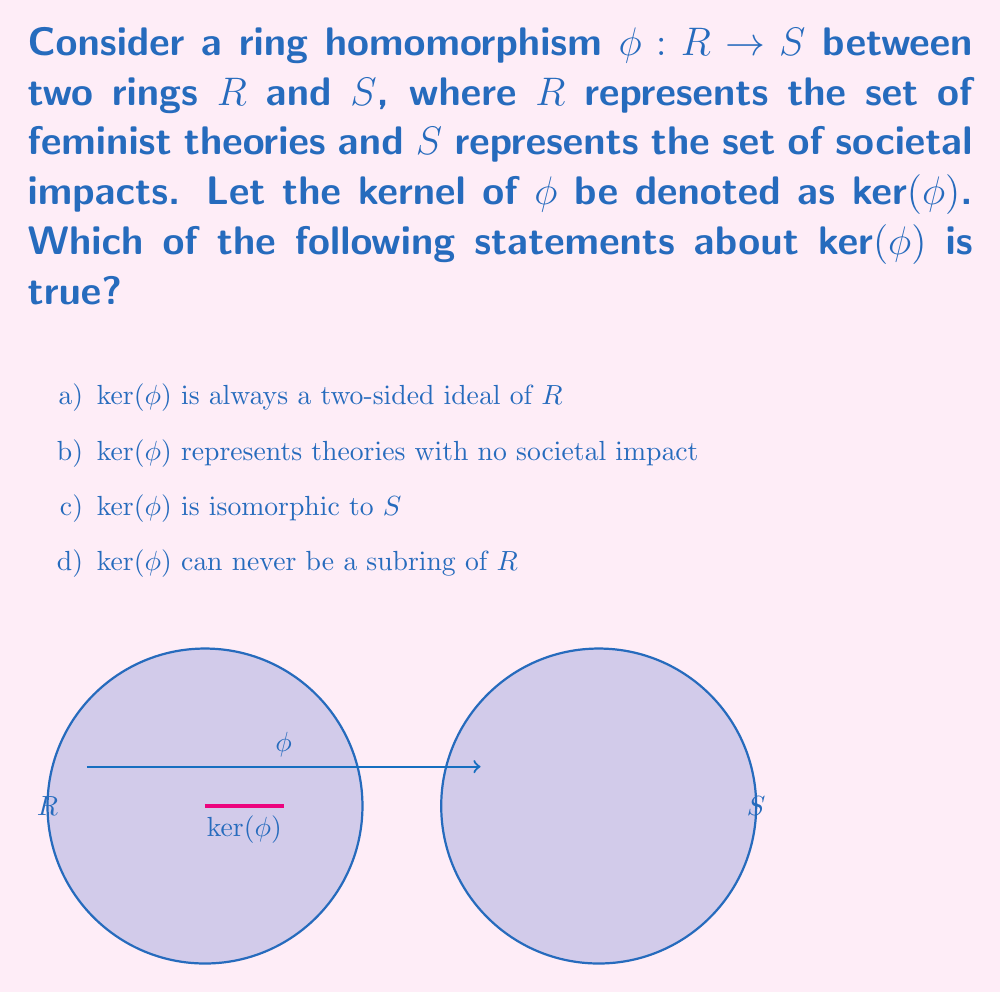Help me with this question. Let's approach this step-by-step:

1) First, recall that for a ring homomorphism $\phi: R \rightarrow S$, the kernel is defined as:

   $\text{ker}(\phi) = \{r \in R : \phi(r) = 0_S\}$

   where $0_S$ is the zero element in $S$.

2) In the context of our feminist theory analogy, $\text{ker}(\phi)$ represents the set of theories that map to "zero impact" in society.

3) Now, let's examine each option:

   a) This statement is true. For any $a \in R$ and $k \in \text{ker}(\phi)$:
      $\phi(ak) = \phi(a)\phi(k) = \phi(a)0_S = 0_S$
      $\phi(ka) = \phi(k)\phi(a) = 0_S\phi(a) = 0_S$
      Thus, both $ak$ and $ka$ are in $\text{ker}(\phi)$, making it a two-sided ideal.

   b) This is also true, as it's essentially the definition of $\text{ker}(\phi)$ in our analogy.

   c) This is false. While $\text{ker}(\phi)$ is related to $S$, it's a subset of $R$, not $S$.

   d) This is false. $\text{ker}(\phi)$ is always a subring of $R$. It's closed under addition and multiplication, and contains the zero element.

4) Therefore, both options a) and b) are correct statements about $\text{ker}(\phi)$.
Answer: a) and b) 